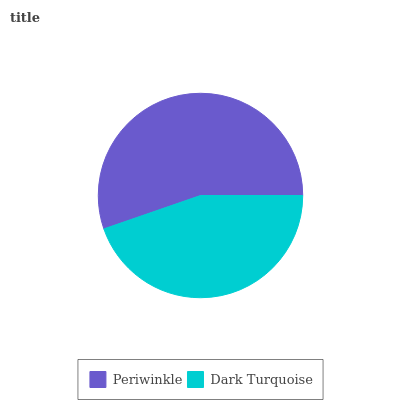Is Dark Turquoise the minimum?
Answer yes or no. Yes. Is Periwinkle the maximum?
Answer yes or no. Yes. Is Dark Turquoise the maximum?
Answer yes or no. No. Is Periwinkle greater than Dark Turquoise?
Answer yes or no. Yes. Is Dark Turquoise less than Periwinkle?
Answer yes or no. Yes. Is Dark Turquoise greater than Periwinkle?
Answer yes or no. No. Is Periwinkle less than Dark Turquoise?
Answer yes or no. No. Is Periwinkle the high median?
Answer yes or no. Yes. Is Dark Turquoise the low median?
Answer yes or no. Yes. Is Dark Turquoise the high median?
Answer yes or no. No. Is Periwinkle the low median?
Answer yes or no. No. 